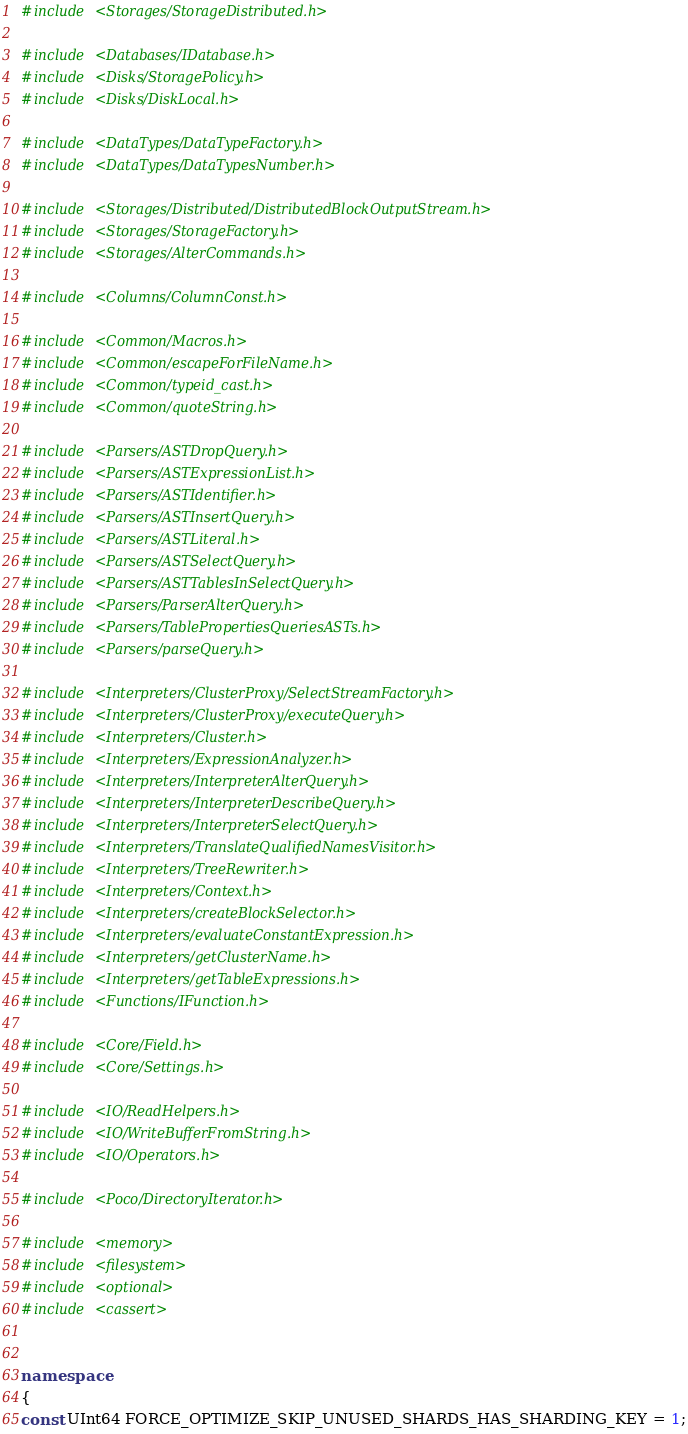Convert code to text. <code><loc_0><loc_0><loc_500><loc_500><_C++_>#include <Storages/StorageDistributed.h>

#include <Databases/IDatabase.h>
#include <Disks/StoragePolicy.h>
#include <Disks/DiskLocal.h>

#include <DataTypes/DataTypeFactory.h>
#include <DataTypes/DataTypesNumber.h>

#include <Storages/Distributed/DistributedBlockOutputStream.h>
#include <Storages/StorageFactory.h>
#include <Storages/AlterCommands.h>

#include <Columns/ColumnConst.h>

#include <Common/Macros.h>
#include <Common/escapeForFileName.h>
#include <Common/typeid_cast.h>
#include <Common/quoteString.h>

#include <Parsers/ASTDropQuery.h>
#include <Parsers/ASTExpressionList.h>
#include <Parsers/ASTIdentifier.h>
#include <Parsers/ASTInsertQuery.h>
#include <Parsers/ASTLiteral.h>
#include <Parsers/ASTSelectQuery.h>
#include <Parsers/ASTTablesInSelectQuery.h>
#include <Parsers/ParserAlterQuery.h>
#include <Parsers/TablePropertiesQueriesASTs.h>
#include <Parsers/parseQuery.h>

#include <Interpreters/ClusterProxy/SelectStreamFactory.h>
#include <Interpreters/ClusterProxy/executeQuery.h>
#include <Interpreters/Cluster.h>
#include <Interpreters/ExpressionAnalyzer.h>
#include <Interpreters/InterpreterAlterQuery.h>
#include <Interpreters/InterpreterDescribeQuery.h>
#include <Interpreters/InterpreterSelectQuery.h>
#include <Interpreters/TranslateQualifiedNamesVisitor.h>
#include <Interpreters/TreeRewriter.h>
#include <Interpreters/Context.h>
#include <Interpreters/createBlockSelector.h>
#include <Interpreters/evaluateConstantExpression.h>
#include <Interpreters/getClusterName.h>
#include <Interpreters/getTableExpressions.h>
#include <Functions/IFunction.h>

#include <Core/Field.h>
#include <Core/Settings.h>

#include <IO/ReadHelpers.h>
#include <IO/WriteBufferFromString.h>
#include <IO/Operators.h>

#include <Poco/DirectoryIterator.h>

#include <memory>
#include <filesystem>
#include <optional>
#include <cassert>


namespace
{
const UInt64 FORCE_OPTIMIZE_SKIP_UNUSED_SHARDS_HAS_SHARDING_KEY = 1;</code> 